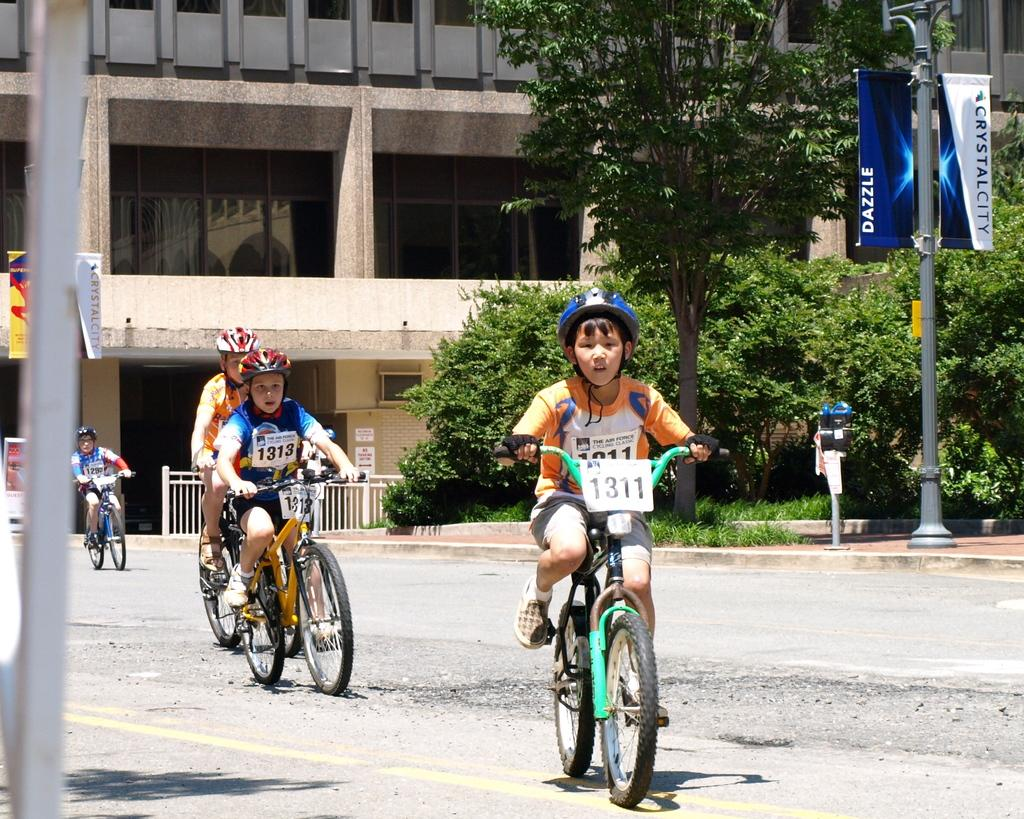What are the boys doing in the image? The boys are riding bicycles in the image. Where are the boys riding their bicycles? The boys are on the road. What can be seen in the background of the image? There is a hoarding, poles, trees, and a building visible in the background of the image. Can you see the elbow of the jellyfish in the image? There is no jellyfish present in the image, and therefore no elbow can be seen. 